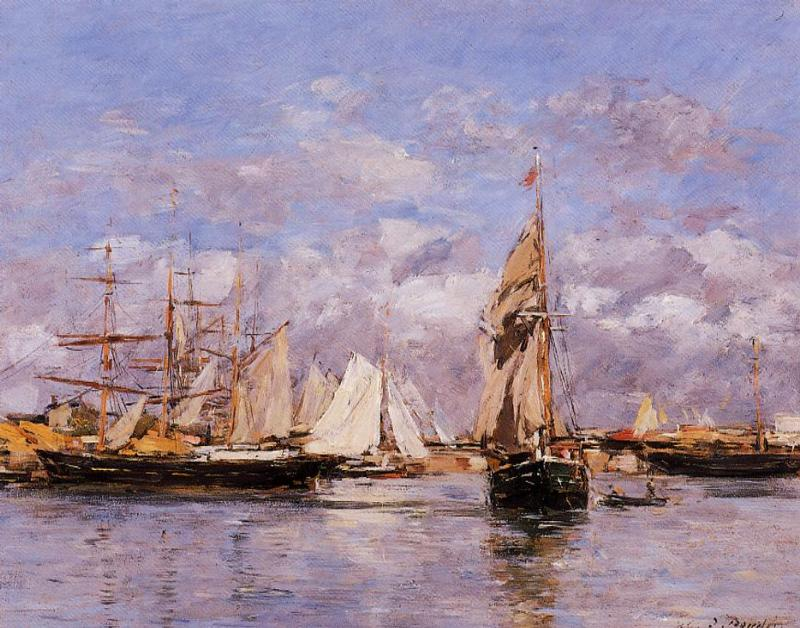What time of day does this image represent, and what clues in the painting lead to that conclusion? The painting appears to capture the harbor in the soft light of either early morning or late afternoon. Clues that suggest this include the length and direction of the shadows cast by the boats and the warm, diffused light that bathes the scene. This lighting creates a tranquil atmosphere and the shadows on the water and the docks suggest a low sun, typical of dawn or dusk. 